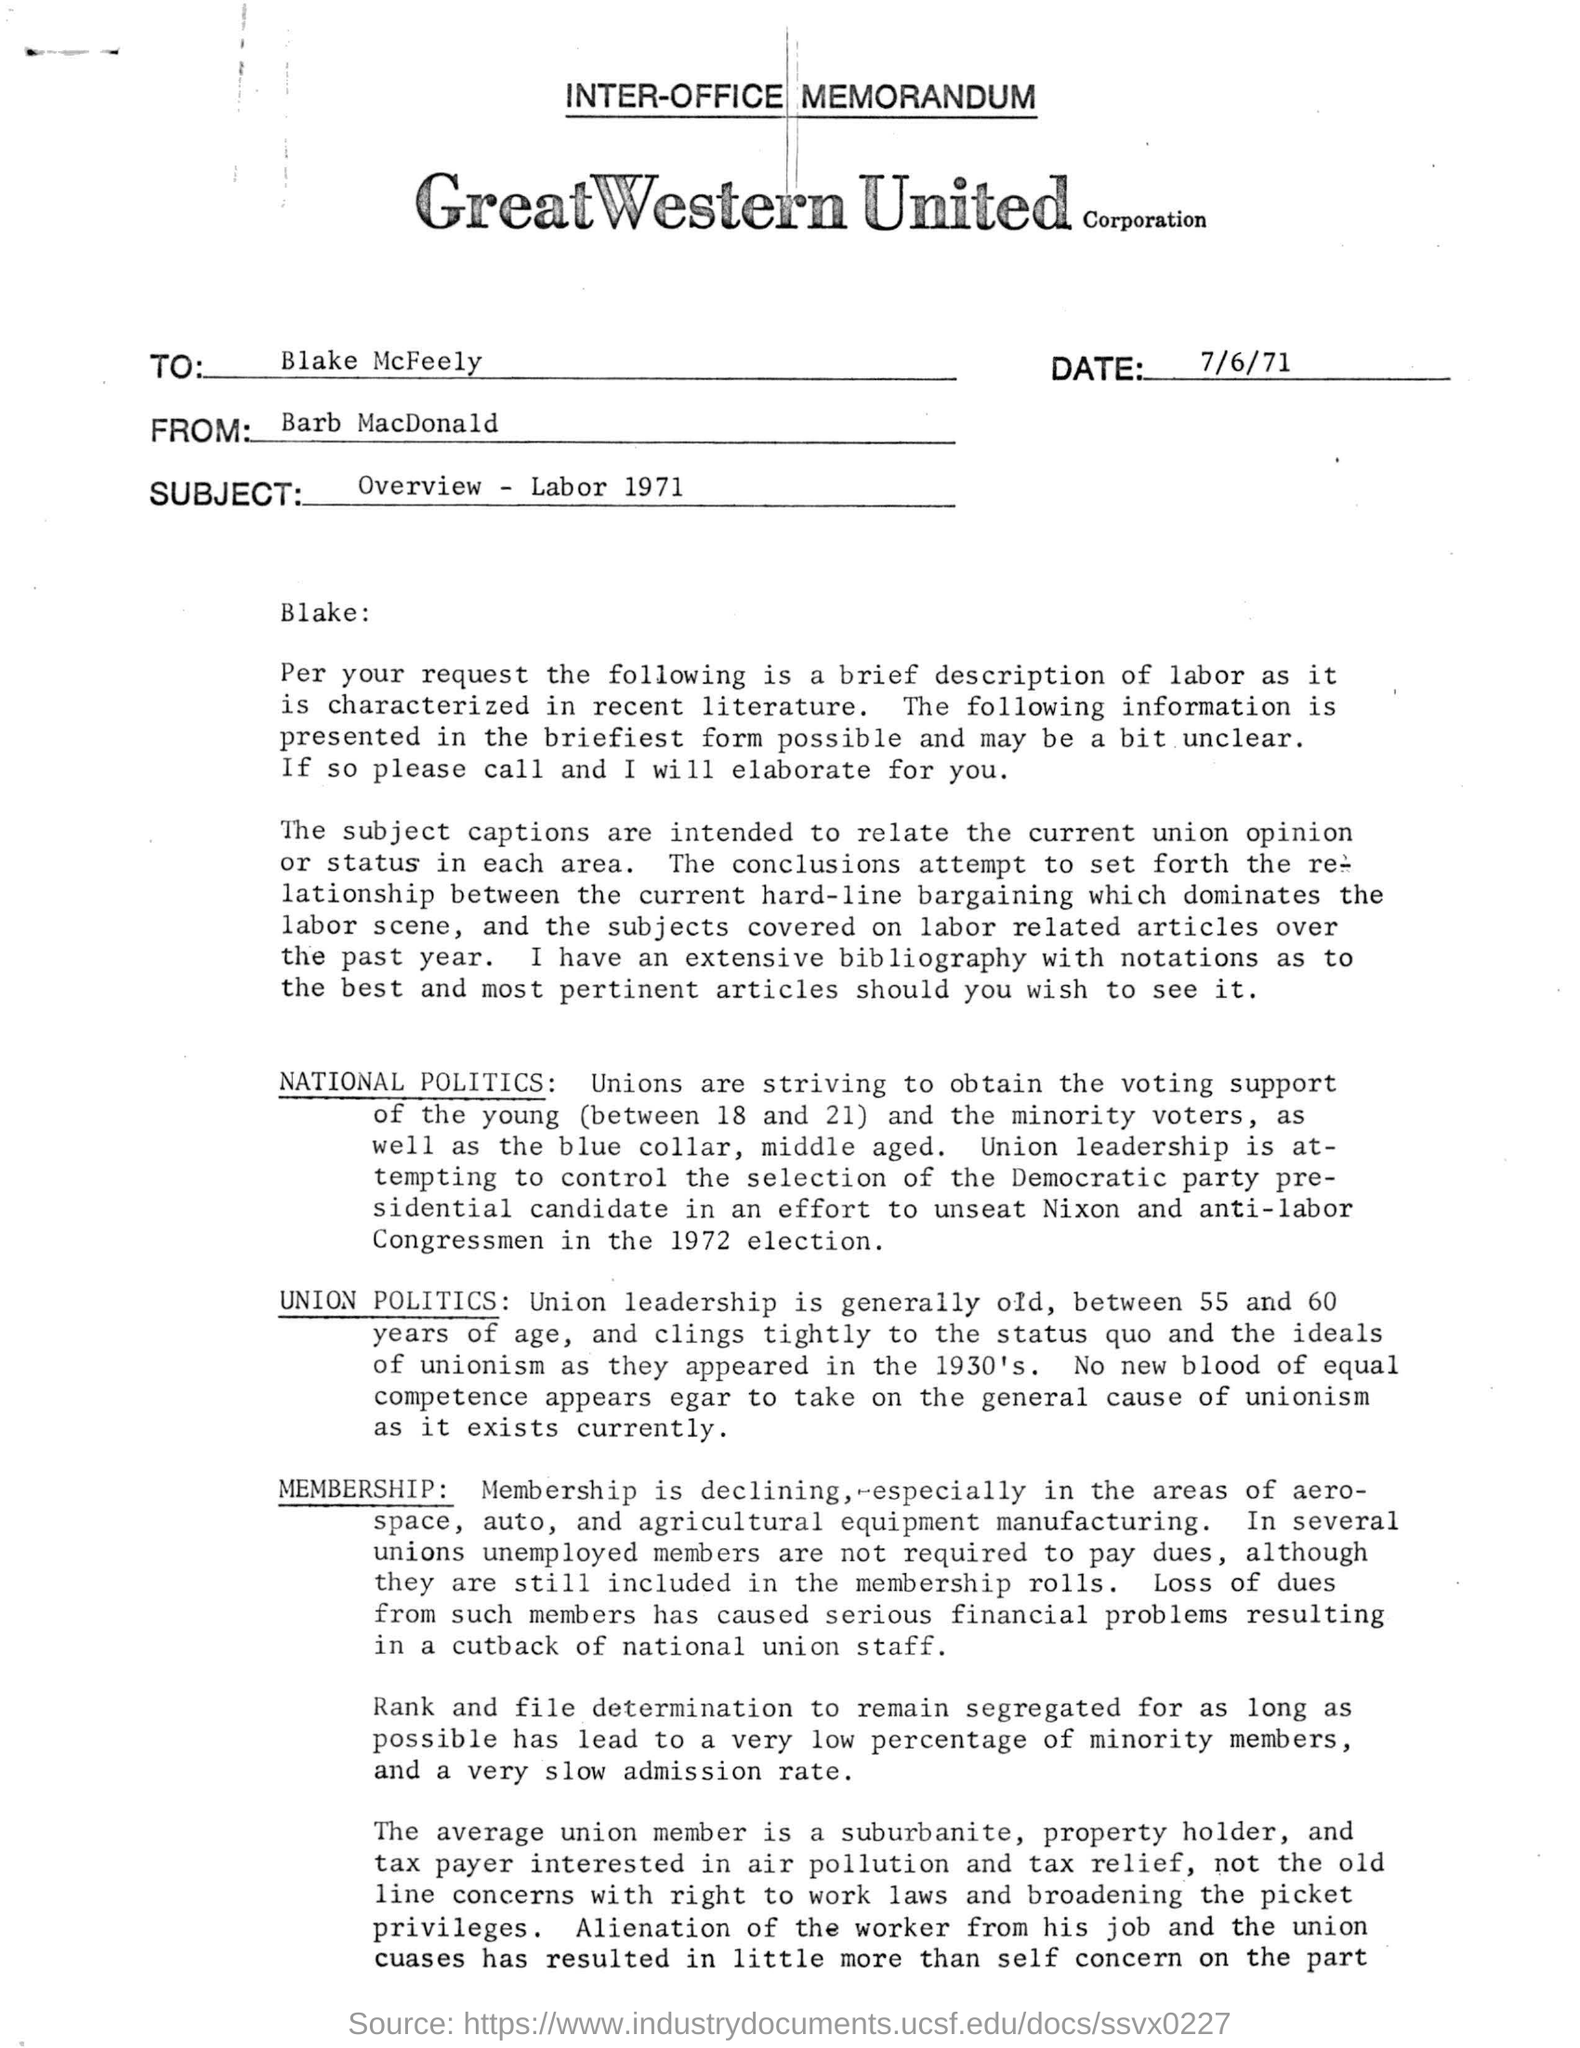Which is the date mentioned in the memorandum?
Ensure brevity in your answer.  7/6/71. Which Corporation is mentioned on the letterhead?
Give a very brief answer. GreatWestern United. What is the subject mentioned in the memorandum?
Make the answer very short. Overview - labor 1971. To whom is the memorandum addressed to ?
Ensure brevity in your answer.  Blake. Who attempts to control the election of the Democratic party presidential candidate?
Provide a succinct answer. Union leadership. What is the age limit of Union leadership?
Your answer should be compact. Between 55 and 60 years of age. 